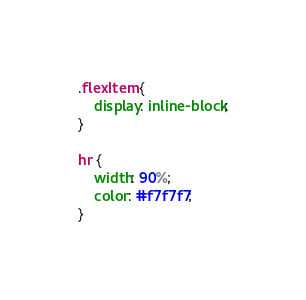Convert code to text. <code><loc_0><loc_0><loc_500><loc_500><_CSS_>.flexItem {
    display: inline-block;
}

hr {
    width: 90%;
    color: #f7f7f7;
}
</code> 